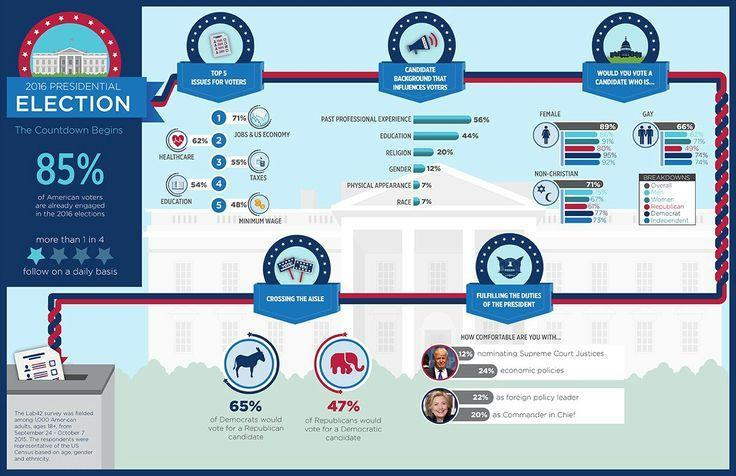What percent of Republicans would vote for a female candidate?
Answer the question with a short phrase. 80% What percent of voters prefer candidates with respect to religion and gender? 32% Overall what percent of voters will vote for a Gay presidential candidate? 66% What percent of Democrats would vote for a non-Christian candidate? 77% Which issue is the biggest one for voters? JOBS & US ECONOMY What proportion of people do not follow presidential election on a daily basis? 3 in 4 